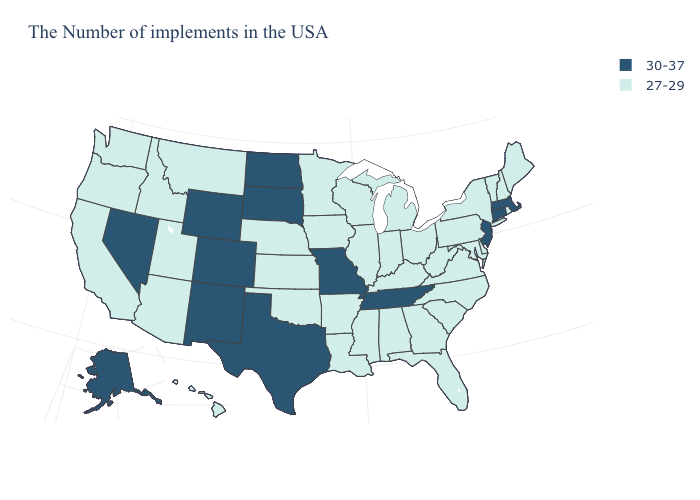Which states have the lowest value in the USA?
Be succinct. Maine, Rhode Island, New Hampshire, Vermont, New York, Delaware, Maryland, Pennsylvania, Virginia, North Carolina, South Carolina, West Virginia, Ohio, Florida, Georgia, Michigan, Kentucky, Indiana, Alabama, Wisconsin, Illinois, Mississippi, Louisiana, Arkansas, Minnesota, Iowa, Kansas, Nebraska, Oklahoma, Utah, Montana, Arizona, Idaho, California, Washington, Oregon, Hawaii. How many symbols are there in the legend?
Keep it brief. 2. Name the states that have a value in the range 27-29?
Short answer required. Maine, Rhode Island, New Hampshire, Vermont, New York, Delaware, Maryland, Pennsylvania, Virginia, North Carolina, South Carolina, West Virginia, Ohio, Florida, Georgia, Michigan, Kentucky, Indiana, Alabama, Wisconsin, Illinois, Mississippi, Louisiana, Arkansas, Minnesota, Iowa, Kansas, Nebraska, Oklahoma, Utah, Montana, Arizona, Idaho, California, Washington, Oregon, Hawaii. What is the highest value in the MidWest ?
Quick response, please. 30-37. What is the value of Georgia?
Give a very brief answer. 27-29. What is the value of Florida?
Keep it brief. 27-29. Name the states that have a value in the range 30-37?
Answer briefly. Massachusetts, Connecticut, New Jersey, Tennessee, Missouri, Texas, South Dakota, North Dakota, Wyoming, Colorado, New Mexico, Nevada, Alaska. What is the lowest value in the MidWest?
Be succinct. 27-29. Name the states that have a value in the range 30-37?
Concise answer only. Massachusetts, Connecticut, New Jersey, Tennessee, Missouri, Texas, South Dakota, North Dakota, Wyoming, Colorado, New Mexico, Nevada, Alaska. Name the states that have a value in the range 30-37?
Short answer required. Massachusetts, Connecticut, New Jersey, Tennessee, Missouri, Texas, South Dakota, North Dakota, Wyoming, Colorado, New Mexico, Nevada, Alaska. Name the states that have a value in the range 30-37?
Be succinct. Massachusetts, Connecticut, New Jersey, Tennessee, Missouri, Texas, South Dakota, North Dakota, Wyoming, Colorado, New Mexico, Nevada, Alaska. What is the value of Rhode Island?
Write a very short answer. 27-29. Does Texas have the same value as Colorado?
Concise answer only. Yes. Which states have the lowest value in the USA?
Write a very short answer. Maine, Rhode Island, New Hampshire, Vermont, New York, Delaware, Maryland, Pennsylvania, Virginia, North Carolina, South Carolina, West Virginia, Ohio, Florida, Georgia, Michigan, Kentucky, Indiana, Alabama, Wisconsin, Illinois, Mississippi, Louisiana, Arkansas, Minnesota, Iowa, Kansas, Nebraska, Oklahoma, Utah, Montana, Arizona, Idaho, California, Washington, Oregon, Hawaii. What is the value of Connecticut?
Keep it brief. 30-37. 